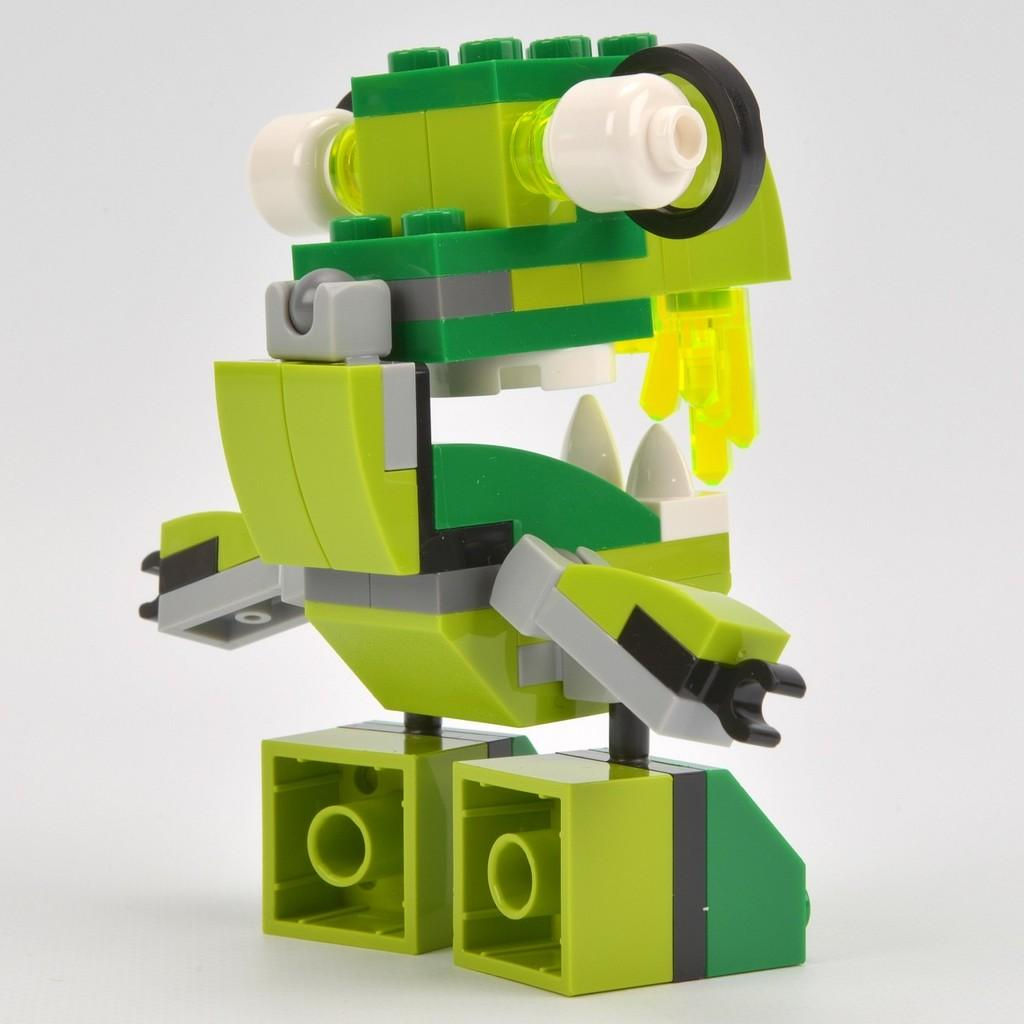What object can be seen in the image? There is a toy in the image. What colors are present on the toy? The toy has green, white, yellow, and black colors. What is the color of the background in the image? The background of the image is white. How much money does the toy hate in the image? There is no indication of money or any emotions in the image, as it features a toy with specific colors and a white background. 